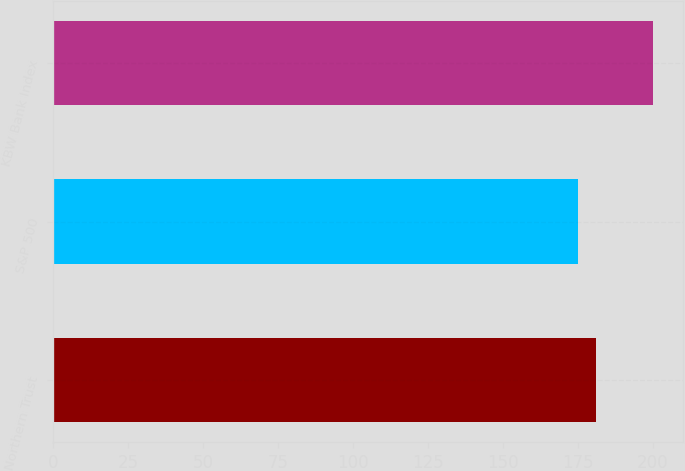Convert chart to OTSL. <chart><loc_0><loc_0><loc_500><loc_500><bar_chart><fcel>Northern Trust<fcel>S&P 500<fcel>KBW Bank Index<nl><fcel>181<fcel>175<fcel>200<nl></chart> 